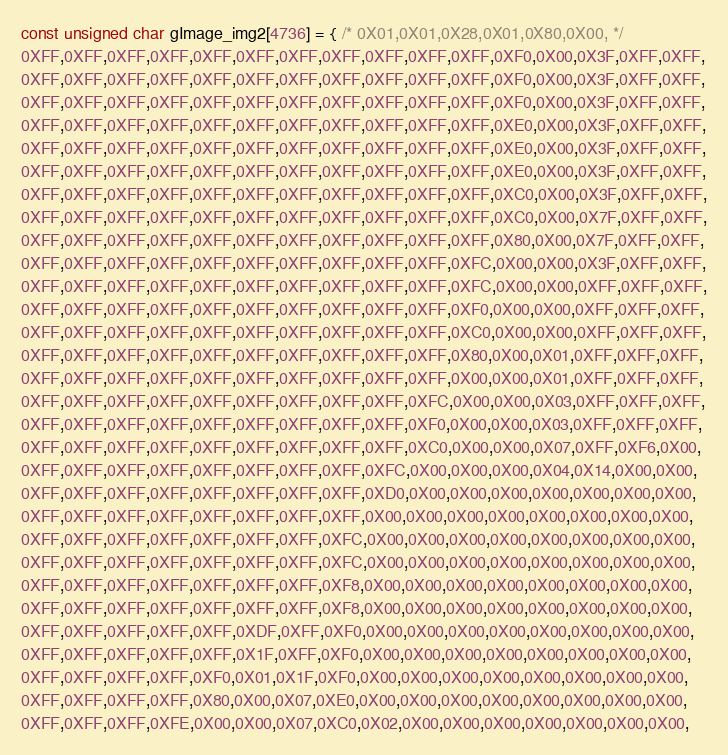Convert code to text. <code><loc_0><loc_0><loc_500><loc_500><_C_>const unsigned char gImage_img2[4736] = { /* 0X01,0X01,0X28,0X01,0X80,0X00, */
0XFF,0XFF,0XFF,0XFF,0XFF,0XFF,0XFF,0XFF,0XFF,0XFF,0XFF,0XF0,0X00,0X3F,0XFF,0XFF,
0XFF,0XFF,0XFF,0XFF,0XFF,0XFF,0XFF,0XFF,0XFF,0XFF,0XFF,0XF0,0X00,0X3F,0XFF,0XFF,
0XFF,0XFF,0XFF,0XFF,0XFF,0XFF,0XFF,0XFF,0XFF,0XFF,0XFF,0XF0,0X00,0X3F,0XFF,0XFF,
0XFF,0XFF,0XFF,0XFF,0XFF,0XFF,0XFF,0XFF,0XFF,0XFF,0XFF,0XE0,0X00,0X3F,0XFF,0XFF,
0XFF,0XFF,0XFF,0XFF,0XFF,0XFF,0XFF,0XFF,0XFF,0XFF,0XFF,0XE0,0X00,0X3F,0XFF,0XFF,
0XFF,0XFF,0XFF,0XFF,0XFF,0XFF,0XFF,0XFF,0XFF,0XFF,0XFF,0XE0,0X00,0X3F,0XFF,0XFF,
0XFF,0XFF,0XFF,0XFF,0XFF,0XFF,0XFF,0XFF,0XFF,0XFF,0XFF,0XC0,0X00,0X3F,0XFF,0XFF,
0XFF,0XFF,0XFF,0XFF,0XFF,0XFF,0XFF,0XFF,0XFF,0XFF,0XFF,0XC0,0X00,0X7F,0XFF,0XFF,
0XFF,0XFF,0XFF,0XFF,0XFF,0XFF,0XFF,0XFF,0XFF,0XFF,0XFF,0X80,0X00,0X7F,0XFF,0XFF,
0XFF,0XFF,0XFF,0XFF,0XFF,0XFF,0XFF,0XFF,0XFF,0XFF,0XFC,0X00,0X00,0X3F,0XFF,0XFF,
0XFF,0XFF,0XFF,0XFF,0XFF,0XFF,0XFF,0XFF,0XFF,0XFF,0XFC,0X00,0X00,0XFF,0XFF,0XFF,
0XFF,0XFF,0XFF,0XFF,0XFF,0XFF,0XFF,0XFF,0XFF,0XFF,0XF0,0X00,0X00,0XFF,0XFF,0XFF,
0XFF,0XFF,0XFF,0XFF,0XFF,0XFF,0XFF,0XFF,0XFF,0XFF,0XC0,0X00,0X00,0XFF,0XFF,0XFF,
0XFF,0XFF,0XFF,0XFF,0XFF,0XFF,0XFF,0XFF,0XFF,0XFF,0X80,0X00,0X01,0XFF,0XFF,0XFF,
0XFF,0XFF,0XFF,0XFF,0XFF,0XFF,0XFF,0XFF,0XFF,0XFF,0X00,0X00,0X01,0XFF,0XFF,0XFF,
0XFF,0XFF,0XFF,0XFF,0XFF,0XFF,0XFF,0XFF,0XFF,0XFC,0X00,0X00,0X03,0XFF,0XFF,0XFF,
0XFF,0XFF,0XFF,0XFF,0XFF,0XFF,0XFF,0XFF,0XFF,0XF0,0X00,0X00,0X03,0XFF,0XFF,0XFF,
0XFF,0XFF,0XFF,0XFF,0XFF,0XFF,0XFF,0XFF,0XFF,0XC0,0X00,0X00,0X07,0XFF,0XF6,0X00,
0XFF,0XFF,0XFF,0XFF,0XFF,0XFF,0XFF,0XFF,0XFC,0X00,0X00,0X00,0X04,0X14,0X00,0X00,
0XFF,0XFF,0XFF,0XFF,0XFF,0XFF,0XFF,0XFF,0XD0,0X00,0X00,0X00,0X00,0X00,0X00,0X00,
0XFF,0XFF,0XFF,0XFF,0XFF,0XFF,0XFF,0XFF,0X00,0X00,0X00,0X00,0X00,0X00,0X00,0X00,
0XFF,0XFF,0XFF,0XFF,0XFF,0XFF,0XFF,0XFC,0X00,0X00,0X00,0X00,0X00,0X00,0X00,0X00,
0XFF,0XFF,0XFF,0XFF,0XFF,0XFF,0XFF,0XFC,0X00,0X00,0X00,0X00,0X00,0X00,0X00,0X00,
0XFF,0XFF,0XFF,0XFF,0XFF,0XFF,0XFF,0XF8,0X00,0X00,0X00,0X00,0X00,0X00,0X00,0X00,
0XFF,0XFF,0XFF,0XFF,0XFF,0XFF,0XFF,0XF8,0X00,0X00,0X00,0X00,0X00,0X00,0X00,0X00,
0XFF,0XFF,0XFF,0XFF,0XFF,0XDF,0XFF,0XF0,0X00,0X00,0X00,0X00,0X00,0X00,0X00,0X00,
0XFF,0XFF,0XFF,0XFF,0XFF,0X1F,0XFF,0XF0,0X00,0X00,0X00,0X00,0X00,0X00,0X00,0X00,
0XFF,0XFF,0XFF,0XFF,0XF0,0X01,0X1F,0XF0,0X00,0X00,0X00,0X00,0X00,0X00,0X00,0X00,
0XFF,0XFF,0XFF,0XFF,0X80,0X00,0X07,0XE0,0X00,0X00,0X00,0X00,0X00,0X00,0X00,0X00,
0XFF,0XFF,0XFF,0XFE,0X00,0X00,0X07,0XC0,0X02,0X00,0X00,0X00,0X00,0X00,0X00,0X00,</code> 